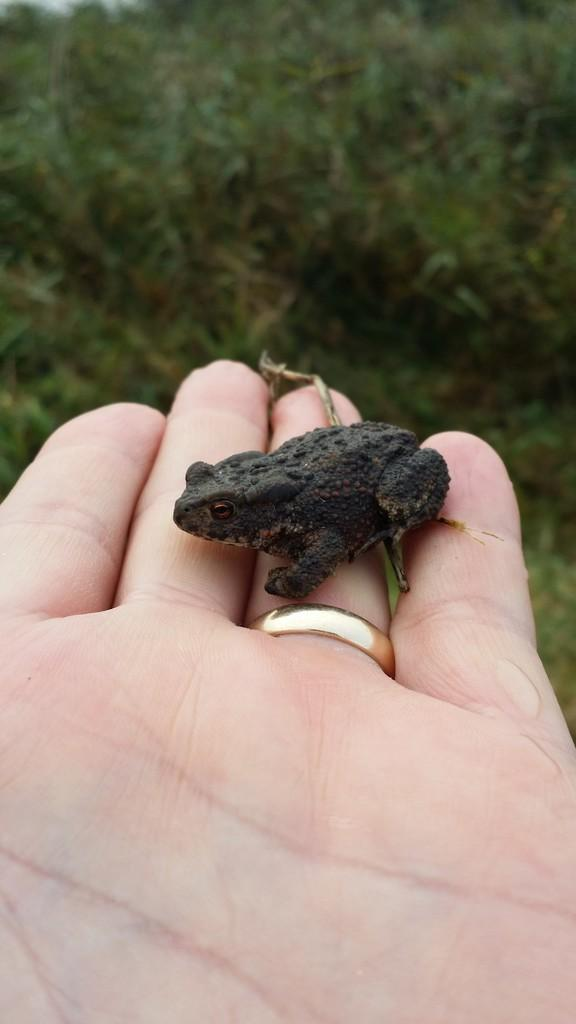What type of animal is in the image? There is a small black frog in the image. Where is the frog located? The frog is on a hand. What can be seen in the background of the image? There are plants in the background of the image. What does the stranger do with the frog in the image? There is no stranger present in the image, so it is not possible to answer that question. 